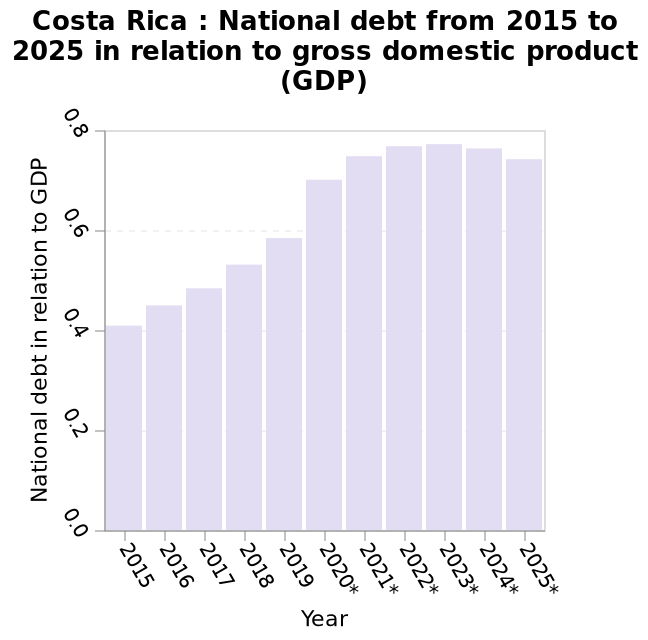<image>
Is Germany the leading country in terms of steel industry employment?  Yes Will Costa Rica's debt be higher in 2023 than any other country?  The description does not provide information about other countries' debt in 2023. Which year is predicted to have an increase in revenue?  2023 